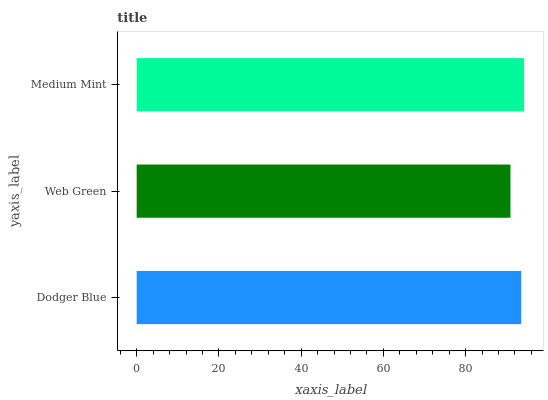Is Web Green the minimum?
Answer yes or no. Yes. Is Medium Mint the maximum?
Answer yes or no. Yes. Is Medium Mint the minimum?
Answer yes or no. No. Is Web Green the maximum?
Answer yes or no. No. Is Medium Mint greater than Web Green?
Answer yes or no. Yes. Is Web Green less than Medium Mint?
Answer yes or no. Yes. Is Web Green greater than Medium Mint?
Answer yes or no. No. Is Medium Mint less than Web Green?
Answer yes or no. No. Is Dodger Blue the high median?
Answer yes or no. Yes. Is Dodger Blue the low median?
Answer yes or no. Yes. Is Medium Mint the high median?
Answer yes or no. No. Is Web Green the low median?
Answer yes or no. No. 